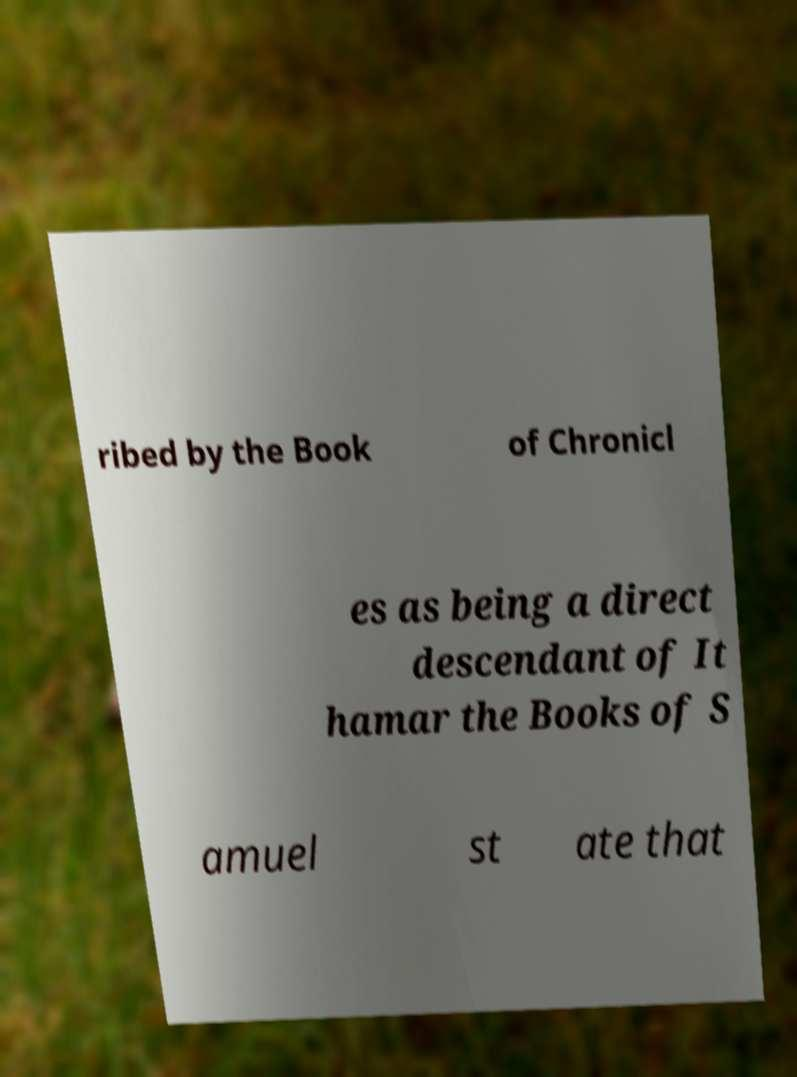There's text embedded in this image that I need extracted. Can you transcribe it verbatim? ribed by the Book of Chronicl es as being a direct descendant of It hamar the Books of S amuel st ate that 